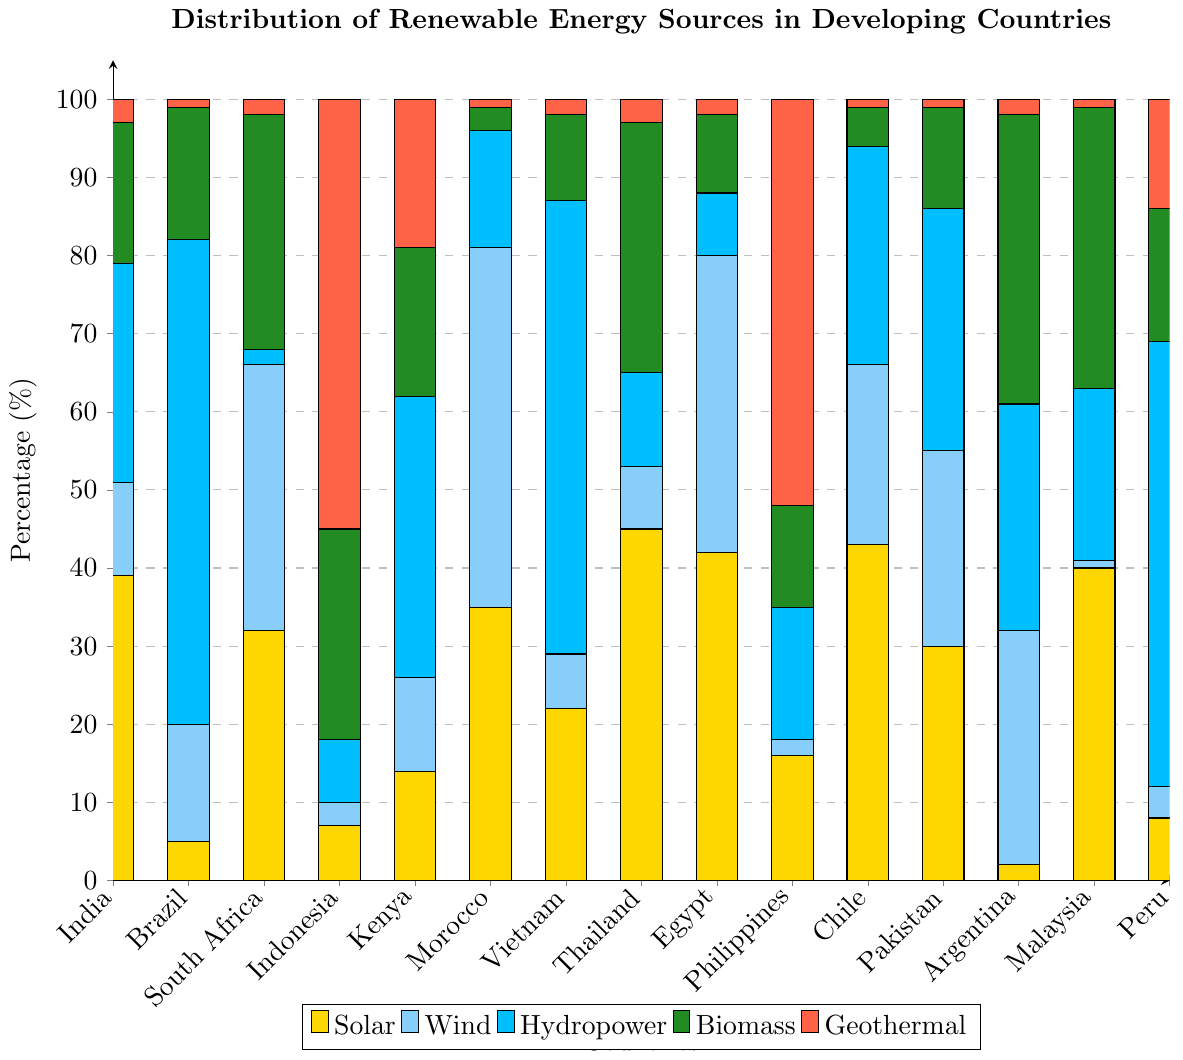Which country relies most on hydropower? Looking at the heights of the blue bars, Brazil has the highest blue bar, indicating the largest reliance on hydropower.
Answer: Brazil Which two countries have the highest combined percentage of solar and wind energy? To determine this, we need to sum the values of solar and wind for each country and then compare. Thailand has 45 (Solar) + 8 (Wind) = 53 and Egypt has 42 (Solar) + 38 (Wind) = 80. Adding these together, Egypt 80 is higher than Thailand 53.
Answer: Egypt, Thailand Which country shows the most diverse use of renewable energy sources (having similar heights across all categories)? By visually inspecting which country has the most balanced bar heights across all colors, Argentina seems to have relatively similar heights in all categories.
Answer: Argentina Which country relies least on geothermal energy? The height of the red bars indicates the reliance on geothermal energy. Malaysia, Brazil, Morocco, Chile, and Thailand each have very short bars representing a very small reliance on geothermal energy. Let's pick Malaysia as it has a very minimal red segment.
Answer: Malaysia Among India, Brazil, and South Africa, which country has the highest total percentage of renewable energy sources summed together? Sum the values for each renewable energy source category for these countries. India: 39+12+28+18+3 = 100, Brazil: 5+15+62+17+1 = 100, South Africa: 32+34+2+30+2 = 100. All three countries sum up to 100, so they are equal.
Answer: Equal, 100% In which country is biomass the primary renewable energy source? By examining the green bars, Argentina has the tallest green bar, indicating the highest use of biomass energy compared to other sources in a country.
Answer: Argentina Compare the reliance on solar energy between India and Egypt. Which one has a higher percentage? The height of the yellow bars for India and Egypt shows their reliance on solar energy. India’s yellow bar is at 39, whereas Egypt’s yellow bar is at 42. So, Egypt has a higher percentage.
Answer: Egypt How much more does Indonesia rely on geothermal compared to India? Indonesia's red bar is at 55, India's red bar is at 3. The difference is 55 - 3 = 52.
Answer: 52 Which country relies least on wind energy? By comparing the heights of the light blue bars, the Philippines’ light blue bar is the shortest at 2.
Answer: Philippines If we consider the average usage of hydropower in the given countries, what is the value? Sum all hydropower values and divide by the number of countries: (28+62+2+8+36+15+58+12+8+17+28+31+29+22+57) / 15 = 413 / 15 ≈ 27.53.
Answer: 27.53 